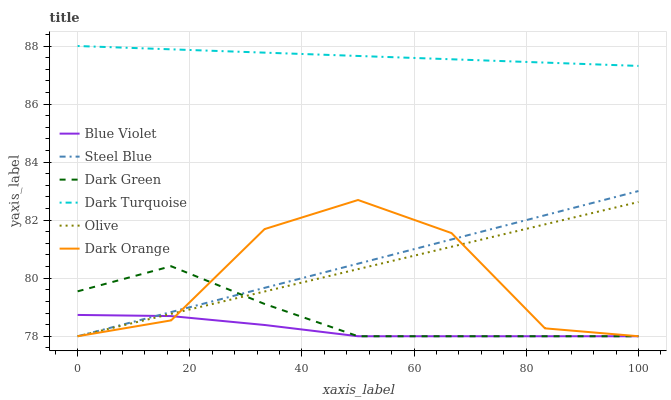Does Blue Violet have the minimum area under the curve?
Answer yes or no. Yes. Does Dark Turquoise have the maximum area under the curve?
Answer yes or no. Yes. Does Steel Blue have the minimum area under the curve?
Answer yes or no. No. Does Steel Blue have the maximum area under the curve?
Answer yes or no. No. Is Steel Blue the smoothest?
Answer yes or no. Yes. Is Dark Orange the roughest?
Answer yes or no. Yes. Is Dark Turquoise the smoothest?
Answer yes or no. No. Is Dark Turquoise the roughest?
Answer yes or no. No. Does Dark Orange have the lowest value?
Answer yes or no. Yes. Does Dark Turquoise have the lowest value?
Answer yes or no. No. Does Dark Turquoise have the highest value?
Answer yes or no. Yes. Does Steel Blue have the highest value?
Answer yes or no. No. Is Steel Blue less than Dark Turquoise?
Answer yes or no. Yes. Is Dark Turquoise greater than Dark Orange?
Answer yes or no. Yes. Does Dark Orange intersect Olive?
Answer yes or no. Yes. Is Dark Orange less than Olive?
Answer yes or no. No. Is Dark Orange greater than Olive?
Answer yes or no. No. Does Steel Blue intersect Dark Turquoise?
Answer yes or no. No. 